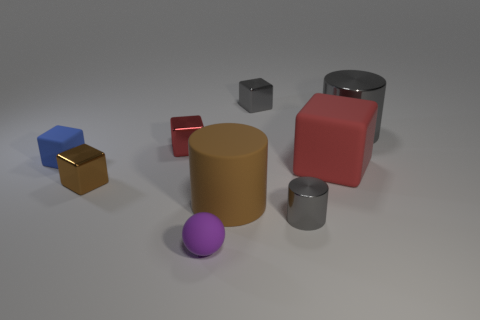Is there anything else that is the same size as the matte ball?
Your answer should be very brief. Yes. What is the size of the brown cylinder that is made of the same material as the large block?
Keep it short and to the point. Large. What number of things are either metallic blocks behind the brown metal block or big cylinders that are behind the big rubber cylinder?
Keep it short and to the point. 3. Is the size of the matte block that is on the right side of the blue object the same as the brown shiny thing?
Give a very brief answer. No. What is the color of the metal object behind the large shiny object?
Offer a terse response. Gray. There is another big object that is the same shape as the blue object; what color is it?
Your response must be concise. Red. There is a cube that is on the left side of the metallic cube that is in front of the tiny blue cube; how many red metallic objects are to the right of it?
Provide a short and direct response. 1. Are there any other things that are the same material as the small blue block?
Offer a very short reply. Yes. Are there fewer large red rubber things that are left of the blue matte cube than tiny gray cubes?
Provide a succinct answer. Yes. Is the color of the tiny matte ball the same as the tiny metal cylinder?
Ensure brevity in your answer.  No. 